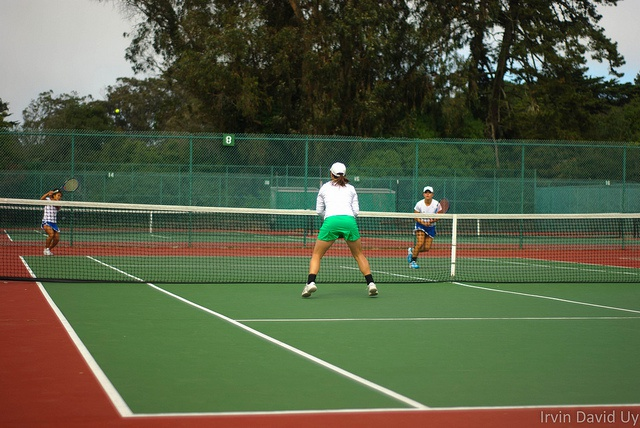Describe the objects in this image and their specific colors. I can see people in darkgray, white, green, tan, and olive tones, people in darkgray, white, brown, black, and maroon tones, people in darkgray, maroon, black, and brown tones, tennis racket in darkgray, gray, and brown tones, and tennis racket in darkgray, gray, darkgreen, black, and olive tones in this image. 